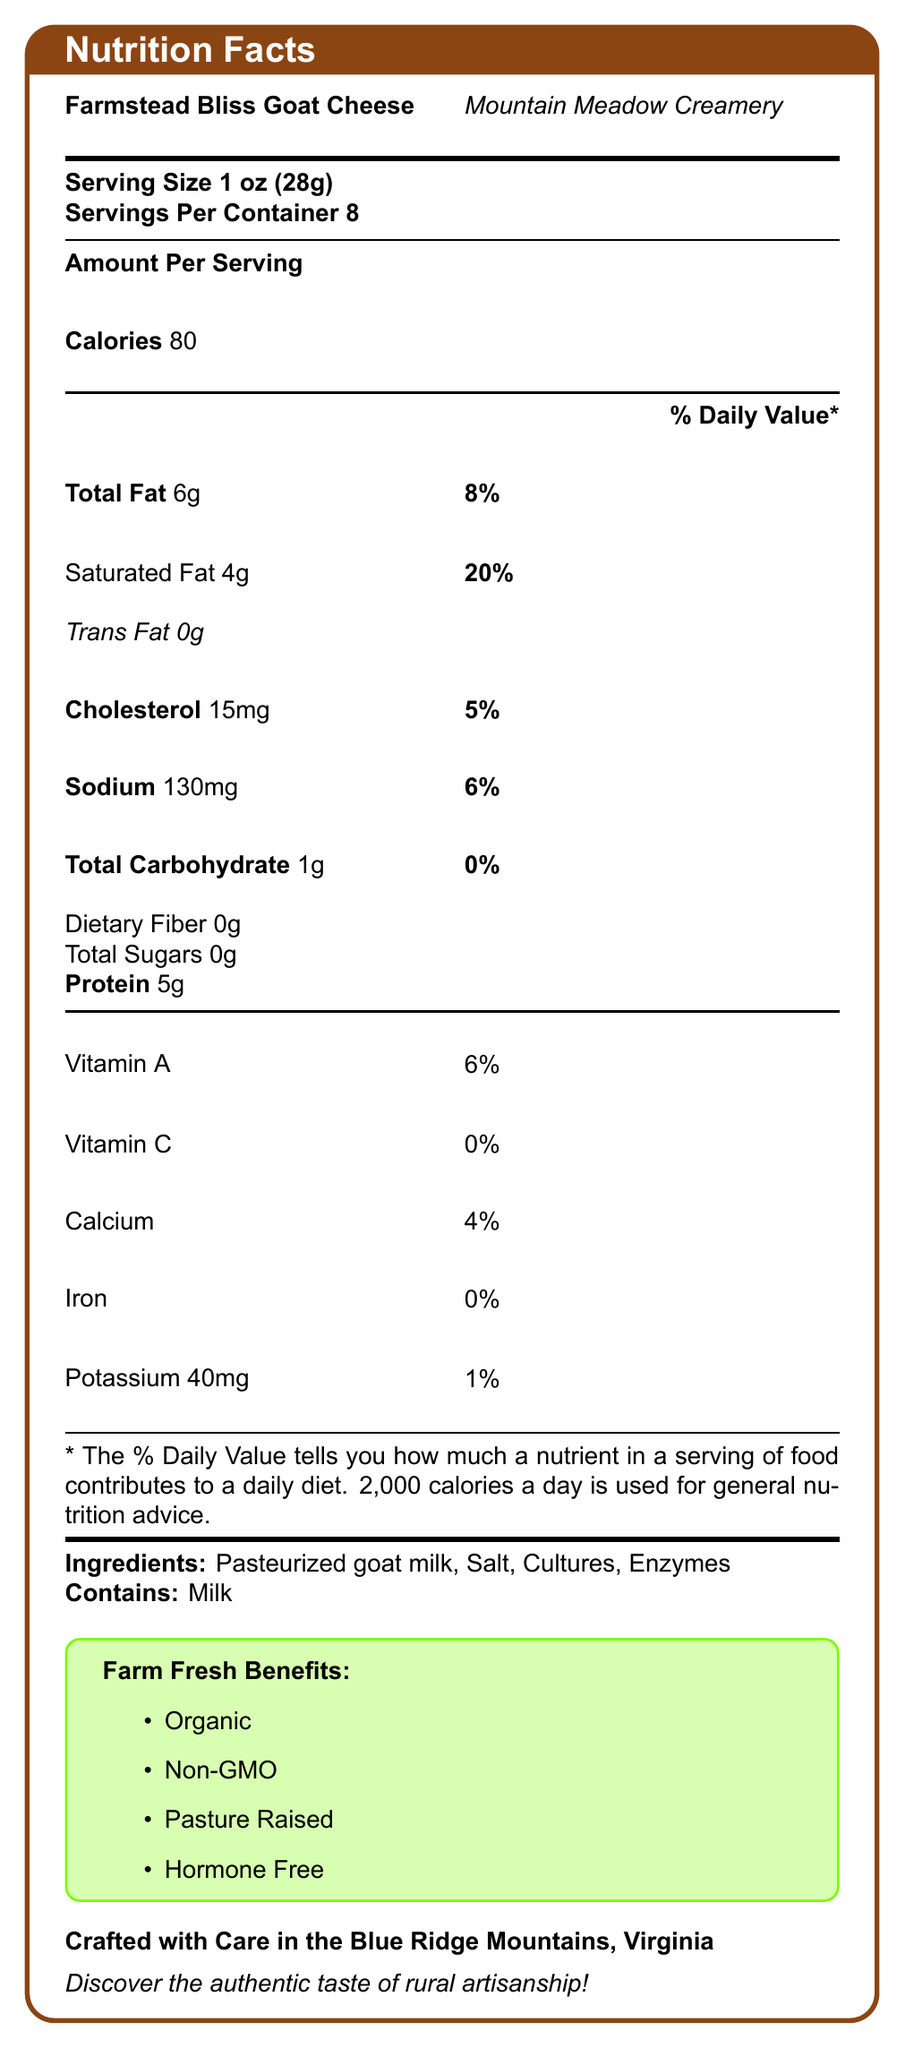what is the serving size for Farmstead Bliss Goat Cheese? The serving size is explicitly stated as "Serving Size 1 oz (28g)" in the document.
Answer: 1 oz (28g) how many servings are in the container? The number of servings per container is listed as "Servings Per Container 8."
Answer: 8 how many calories are in one serving of the goat cheese? The document lists the calories per serving as "Calories 80."
Answer: 80 is the goat cheese organic? The document states in the section "Farm Fresh Benefits" that the cheese is "Organic."
Answer: Yes what is the amount of saturated fat in one serving? The amount of saturated fat per serving is specified as "Saturated Fat 4g."
Answer: 4g what is one of the awards received by Farmstead Bliss Goat Cheese? The document lists two awards, one of which is "2022 American Cheese Society - Silver Medal."
Answer: 2022 American Cheese Society - Silver Medal how much protein is there in one serving? The amount of protein per serving is listed as "Protein 5g."
Answer: 5g what is the daily value percentage of sodium in one serving? A. 3% B. 6% C. 10% D. 15% The daily value percentage for sodium is given as "Sodium 130mg" with a daily value of "6%."
Answer: B which of the following ingredients is *not* part of the goat cheese? A. Salt B. Pasteurized goat milk C. Preservatives D. Cultures The listed ingredients are "Pasteurized goat milk, Salt, Cultures, Enzymes," and preservatives are not mentioned.
Answer: C is there any dietary fiber in Farmstead Bliss Goat Cheese? The document mentions "Dietary Fiber 0g," indicating there is no dietary fiber.
Answer: No is the goat cheese made using traditional methods? The document states, "Hand-crafted in small batches using traditional methods."
Answer: Yes how is the calcium content described in terms of daily value percentage? The document lists calcium with a daily value of "4%."
Answer: 4% where is Mountain Meadow Creamery located? The document specifies "Crafted with Care in the Blue Ridge Mountains, Virginia."
Answer: Blue Ridge Mountains, Virginia describe the texture and flavor profile of Farmstead Bliss Goat Cheese. The document states, "Texture: Creamy and slightly crumbly," and "Flavor profile: Tangy with a hint of sweetness."
Answer: Creamy and slightly crumbly texture with a tangy flavor and a hint of sweetness what is the goat breed used in Farmstead Bliss Goat Cheese? The document mentions, "Goat breed: Alpine."
Answer: Alpine can you tell if this goat cheese contains any genetically modified organisms (GMOs)? The document indicates in the "Farm Fresh Benefits" section that it is "Non-GMO."
Answer: No, it is non-GMO is there any information about the brand's sustainability practices? The document lists multiple sustainability practices including "Solar-powered creamery," "Rainwater harvesting," and "Composting of organic waste."
Answer: Yes what is the cholesterol amount in one serving? The document specifies "Cholesterol 15mg."
Answer: 15mg based on the document, can you determine if the goats were raised with hormones? The document mentions in the "Farm Fresh Benefits" section that it is "Hormone Free."
Answer: No, they are hormone-free summarize the main idea of the document. The document is well-organized, listing nutritional information, ingredients, and special attributes of the goat cheese, including the origin, awards, and sustainability practices. It highlights the organic and non-GMO aspects, texture and flavor profile, and recommended pairings.
Answer: The document provides a detailed overview of the nutritional facts, ingredients, and special attributes of Farmstead Bliss Goat Cheese from Mountain Meadow Creamery. This includes serving size, calories, macronutrients, vitamins, and minerals, along with information on organic and non-GMO certifications, sustainability practices, creamery location, artisanal process, and awards. 